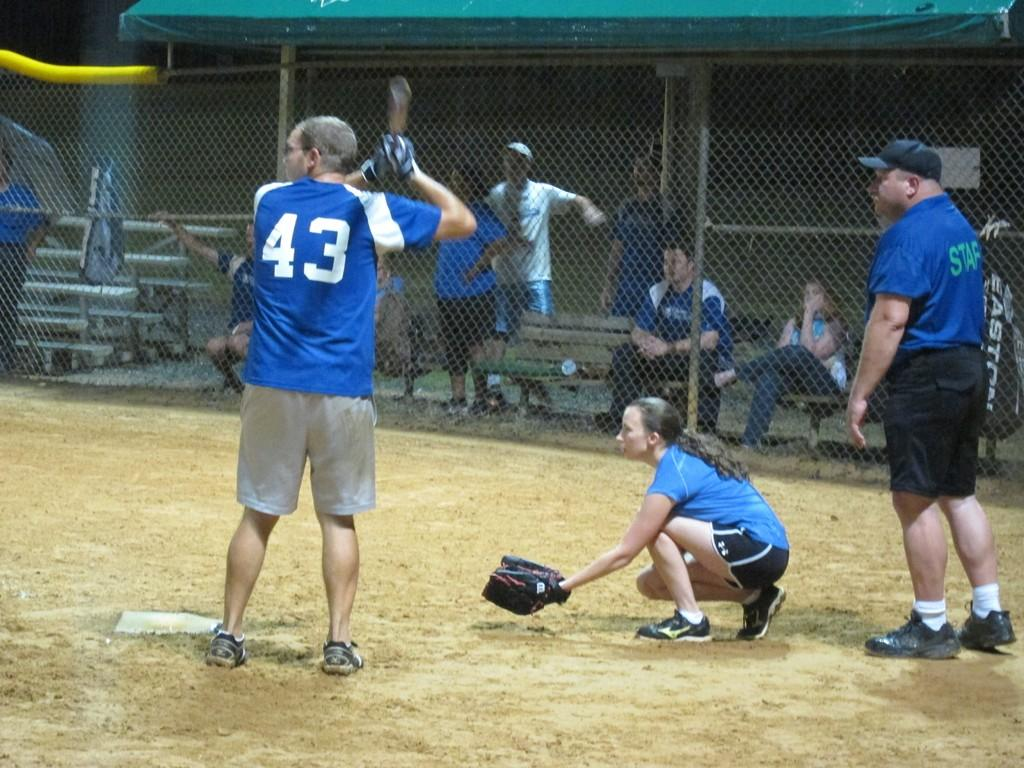Provide a one-sentence caption for the provided image. Baseball player 43 in a blue jersey is at bat. 